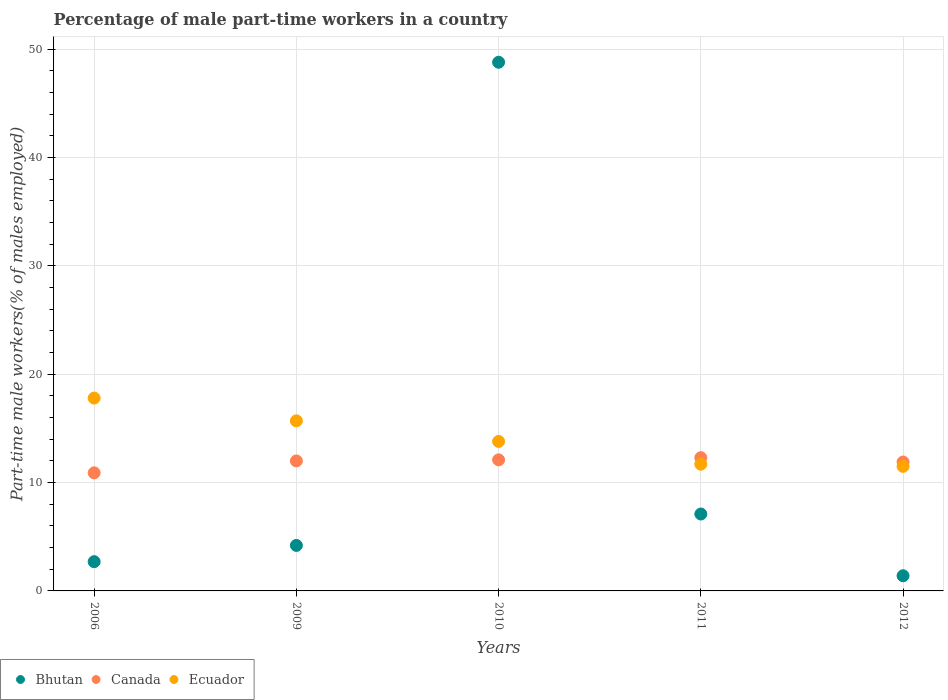How many different coloured dotlines are there?
Keep it short and to the point. 3. Is the number of dotlines equal to the number of legend labels?
Offer a very short reply. Yes. What is the percentage of male part-time workers in Canada in 2011?
Your answer should be compact. 12.3. Across all years, what is the maximum percentage of male part-time workers in Ecuador?
Provide a succinct answer. 17.8. Across all years, what is the minimum percentage of male part-time workers in Bhutan?
Your answer should be compact. 1.4. What is the total percentage of male part-time workers in Canada in the graph?
Keep it short and to the point. 59.2. What is the difference between the percentage of male part-time workers in Canada in 2006 and that in 2009?
Offer a very short reply. -1.1. What is the difference between the percentage of male part-time workers in Canada in 2011 and the percentage of male part-time workers in Bhutan in 2009?
Provide a succinct answer. 8.1. What is the average percentage of male part-time workers in Canada per year?
Your answer should be very brief. 11.84. In the year 2006, what is the difference between the percentage of male part-time workers in Canada and percentage of male part-time workers in Ecuador?
Ensure brevity in your answer.  -6.9. What is the ratio of the percentage of male part-time workers in Ecuador in 2006 to that in 2011?
Provide a succinct answer. 1.52. Is the percentage of male part-time workers in Bhutan in 2009 less than that in 2012?
Your answer should be very brief. No. What is the difference between the highest and the second highest percentage of male part-time workers in Ecuador?
Your answer should be compact. 2.1. What is the difference between the highest and the lowest percentage of male part-time workers in Ecuador?
Provide a succinct answer. 6.3. In how many years, is the percentage of male part-time workers in Ecuador greater than the average percentage of male part-time workers in Ecuador taken over all years?
Provide a succinct answer. 2. Is the sum of the percentage of male part-time workers in Bhutan in 2006 and 2011 greater than the maximum percentage of male part-time workers in Ecuador across all years?
Your answer should be compact. No. How many dotlines are there?
Provide a short and direct response. 3. How many years are there in the graph?
Your response must be concise. 5. Are the values on the major ticks of Y-axis written in scientific E-notation?
Provide a short and direct response. No. How many legend labels are there?
Ensure brevity in your answer.  3. How are the legend labels stacked?
Offer a very short reply. Horizontal. What is the title of the graph?
Your answer should be very brief. Percentage of male part-time workers in a country. Does "France" appear as one of the legend labels in the graph?
Keep it short and to the point. No. What is the label or title of the Y-axis?
Give a very brief answer. Part-time male workers(% of males employed). What is the Part-time male workers(% of males employed) of Bhutan in 2006?
Offer a terse response. 2.7. What is the Part-time male workers(% of males employed) of Canada in 2006?
Provide a succinct answer. 10.9. What is the Part-time male workers(% of males employed) in Ecuador in 2006?
Your answer should be compact. 17.8. What is the Part-time male workers(% of males employed) of Bhutan in 2009?
Keep it short and to the point. 4.2. What is the Part-time male workers(% of males employed) of Ecuador in 2009?
Make the answer very short. 15.7. What is the Part-time male workers(% of males employed) of Bhutan in 2010?
Your response must be concise. 48.8. What is the Part-time male workers(% of males employed) of Canada in 2010?
Your answer should be very brief. 12.1. What is the Part-time male workers(% of males employed) of Ecuador in 2010?
Keep it short and to the point. 13.8. What is the Part-time male workers(% of males employed) of Bhutan in 2011?
Your answer should be very brief. 7.1. What is the Part-time male workers(% of males employed) in Canada in 2011?
Your response must be concise. 12.3. What is the Part-time male workers(% of males employed) in Ecuador in 2011?
Your response must be concise. 11.7. What is the Part-time male workers(% of males employed) in Bhutan in 2012?
Your response must be concise. 1.4. What is the Part-time male workers(% of males employed) in Canada in 2012?
Offer a very short reply. 11.9. Across all years, what is the maximum Part-time male workers(% of males employed) in Bhutan?
Your answer should be very brief. 48.8. Across all years, what is the maximum Part-time male workers(% of males employed) of Canada?
Offer a very short reply. 12.3. Across all years, what is the maximum Part-time male workers(% of males employed) of Ecuador?
Offer a very short reply. 17.8. Across all years, what is the minimum Part-time male workers(% of males employed) in Bhutan?
Make the answer very short. 1.4. Across all years, what is the minimum Part-time male workers(% of males employed) in Canada?
Your answer should be compact. 10.9. Across all years, what is the minimum Part-time male workers(% of males employed) in Ecuador?
Make the answer very short. 11.5. What is the total Part-time male workers(% of males employed) of Bhutan in the graph?
Your answer should be very brief. 64.2. What is the total Part-time male workers(% of males employed) of Canada in the graph?
Make the answer very short. 59.2. What is the total Part-time male workers(% of males employed) of Ecuador in the graph?
Give a very brief answer. 70.5. What is the difference between the Part-time male workers(% of males employed) in Bhutan in 2006 and that in 2009?
Offer a very short reply. -1.5. What is the difference between the Part-time male workers(% of males employed) in Bhutan in 2006 and that in 2010?
Offer a terse response. -46.1. What is the difference between the Part-time male workers(% of males employed) of Canada in 2006 and that in 2010?
Your answer should be compact. -1.2. What is the difference between the Part-time male workers(% of males employed) in Bhutan in 2006 and that in 2011?
Your answer should be very brief. -4.4. What is the difference between the Part-time male workers(% of males employed) of Ecuador in 2006 and that in 2011?
Offer a very short reply. 6.1. What is the difference between the Part-time male workers(% of males employed) of Canada in 2006 and that in 2012?
Keep it short and to the point. -1. What is the difference between the Part-time male workers(% of males employed) of Ecuador in 2006 and that in 2012?
Offer a very short reply. 6.3. What is the difference between the Part-time male workers(% of males employed) of Bhutan in 2009 and that in 2010?
Keep it short and to the point. -44.6. What is the difference between the Part-time male workers(% of males employed) of Ecuador in 2009 and that in 2010?
Your answer should be compact. 1.9. What is the difference between the Part-time male workers(% of males employed) of Canada in 2009 and that in 2011?
Your answer should be compact. -0.3. What is the difference between the Part-time male workers(% of males employed) of Ecuador in 2009 and that in 2011?
Offer a terse response. 4. What is the difference between the Part-time male workers(% of males employed) in Bhutan in 2009 and that in 2012?
Offer a terse response. 2.8. What is the difference between the Part-time male workers(% of males employed) of Canada in 2009 and that in 2012?
Your answer should be compact. 0.1. What is the difference between the Part-time male workers(% of males employed) of Ecuador in 2009 and that in 2012?
Make the answer very short. 4.2. What is the difference between the Part-time male workers(% of males employed) in Bhutan in 2010 and that in 2011?
Keep it short and to the point. 41.7. What is the difference between the Part-time male workers(% of males employed) in Ecuador in 2010 and that in 2011?
Your response must be concise. 2.1. What is the difference between the Part-time male workers(% of males employed) in Bhutan in 2010 and that in 2012?
Offer a terse response. 47.4. What is the difference between the Part-time male workers(% of males employed) in Canada in 2006 and the Part-time male workers(% of males employed) in Ecuador in 2010?
Ensure brevity in your answer.  -2.9. What is the difference between the Part-time male workers(% of males employed) in Bhutan in 2006 and the Part-time male workers(% of males employed) in Canada in 2011?
Offer a very short reply. -9.6. What is the difference between the Part-time male workers(% of males employed) in Bhutan in 2006 and the Part-time male workers(% of males employed) in Ecuador in 2011?
Offer a very short reply. -9. What is the difference between the Part-time male workers(% of males employed) of Bhutan in 2006 and the Part-time male workers(% of males employed) of Canada in 2012?
Give a very brief answer. -9.2. What is the difference between the Part-time male workers(% of males employed) of Bhutan in 2009 and the Part-time male workers(% of males employed) of Canada in 2010?
Your response must be concise. -7.9. What is the difference between the Part-time male workers(% of males employed) in Bhutan in 2009 and the Part-time male workers(% of males employed) in Ecuador in 2010?
Give a very brief answer. -9.6. What is the difference between the Part-time male workers(% of males employed) in Canada in 2009 and the Part-time male workers(% of males employed) in Ecuador in 2010?
Your response must be concise. -1.8. What is the difference between the Part-time male workers(% of males employed) of Bhutan in 2009 and the Part-time male workers(% of males employed) of Canada in 2012?
Give a very brief answer. -7.7. What is the difference between the Part-time male workers(% of males employed) of Bhutan in 2009 and the Part-time male workers(% of males employed) of Ecuador in 2012?
Keep it short and to the point. -7.3. What is the difference between the Part-time male workers(% of males employed) of Bhutan in 2010 and the Part-time male workers(% of males employed) of Canada in 2011?
Make the answer very short. 36.5. What is the difference between the Part-time male workers(% of males employed) of Bhutan in 2010 and the Part-time male workers(% of males employed) of Ecuador in 2011?
Ensure brevity in your answer.  37.1. What is the difference between the Part-time male workers(% of males employed) in Canada in 2010 and the Part-time male workers(% of males employed) in Ecuador in 2011?
Your response must be concise. 0.4. What is the difference between the Part-time male workers(% of males employed) in Bhutan in 2010 and the Part-time male workers(% of males employed) in Canada in 2012?
Give a very brief answer. 36.9. What is the difference between the Part-time male workers(% of males employed) in Bhutan in 2010 and the Part-time male workers(% of males employed) in Ecuador in 2012?
Your response must be concise. 37.3. What is the difference between the Part-time male workers(% of males employed) of Bhutan in 2011 and the Part-time male workers(% of males employed) of Canada in 2012?
Your answer should be compact. -4.8. What is the difference between the Part-time male workers(% of males employed) in Bhutan in 2011 and the Part-time male workers(% of males employed) in Ecuador in 2012?
Your answer should be compact. -4.4. What is the average Part-time male workers(% of males employed) in Bhutan per year?
Make the answer very short. 12.84. What is the average Part-time male workers(% of males employed) in Canada per year?
Your answer should be compact. 11.84. What is the average Part-time male workers(% of males employed) in Ecuador per year?
Provide a short and direct response. 14.1. In the year 2006, what is the difference between the Part-time male workers(% of males employed) of Bhutan and Part-time male workers(% of males employed) of Ecuador?
Make the answer very short. -15.1. In the year 2006, what is the difference between the Part-time male workers(% of males employed) of Canada and Part-time male workers(% of males employed) of Ecuador?
Provide a succinct answer. -6.9. In the year 2010, what is the difference between the Part-time male workers(% of males employed) of Bhutan and Part-time male workers(% of males employed) of Canada?
Give a very brief answer. 36.7. In the year 2010, what is the difference between the Part-time male workers(% of males employed) in Bhutan and Part-time male workers(% of males employed) in Ecuador?
Keep it short and to the point. 35. In the year 2010, what is the difference between the Part-time male workers(% of males employed) in Canada and Part-time male workers(% of males employed) in Ecuador?
Ensure brevity in your answer.  -1.7. In the year 2012, what is the difference between the Part-time male workers(% of males employed) in Bhutan and Part-time male workers(% of males employed) in Canada?
Provide a succinct answer. -10.5. In the year 2012, what is the difference between the Part-time male workers(% of males employed) of Bhutan and Part-time male workers(% of males employed) of Ecuador?
Keep it short and to the point. -10.1. In the year 2012, what is the difference between the Part-time male workers(% of males employed) of Canada and Part-time male workers(% of males employed) of Ecuador?
Give a very brief answer. 0.4. What is the ratio of the Part-time male workers(% of males employed) in Bhutan in 2006 to that in 2009?
Ensure brevity in your answer.  0.64. What is the ratio of the Part-time male workers(% of males employed) of Canada in 2006 to that in 2009?
Your answer should be compact. 0.91. What is the ratio of the Part-time male workers(% of males employed) in Ecuador in 2006 to that in 2009?
Give a very brief answer. 1.13. What is the ratio of the Part-time male workers(% of males employed) in Bhutan in 2006 to that in 2010?
Make the answer very short. 0.06. What is the ratio of the Part-time male workers(% of males employed) of Canada in 2006 to that in 2010?
Provide a short and direct response. 0.9. What is the ratio of the Part-time male workers(% of males employed) in Ecuador in 2006 to that in 2010?
Make the answer very short. 1.29. What is the ratio of the Part-time male workers(% of males employed) in Bhutan in 2006 to that in 2011?
Offer a very short reply. 0.38. What is the ratio of the Part-time male workers(% of males employed) of Canada in 2006 to that in 2011?
Offer a very short reply. 0.89. What is the ratio of the Part-time male workers(% of males employed) of Ecuador in 2006 to that in 2011?
Make the answer very short. 1.52. What is the ratio of the Part-time male workers(% of males employed) in Bhutan in 2006 to that in 2012?
Your answer should be very brief. 1.93. What is the ratio of the Part-time male workers(% of males employed) in Canada in 2006 to that in 2012?
Offer a terse response. 0.92. What is the ratio of the Part-time male workers(% of males employed) in Ecuador in 2006 to that in 2012?
Offer a very short reply. 1.55. What is the ratio of the Part-time male workers(% of males employed) in Bhutan in 2009 to that in 2010?
Provide a short and direct response. 0.09. What is the ratio of the Part-time male workers(% of males employed) in Ecuador in 2009 to that in 2010?
Keep it short and to the point. 1.14. What is the ratio of the Part-time male workers(% of males employed) in Bhutan in 2009 to that in 2011?
Your response must be concise. 0.59. What is the ratio of the Part-time male workers(% of males employed) in Canada in 2009 to that in 2011?
Make the answer very short. 0.98. What is the ratio of the Part-time male workers(% of males employed) in Ecuador in 2009 to that in 2011?
Make the answer very short. 1.34. What is the ratio of the Part-time male workers(% of males employed) of Canada in 2009 to that in 2012?
Offer a very short reply. 1.01. What is the ratio of the Part-time male workers(% of males employed) of Ecuador in 2009 to that in 2012?
Provide a succinct answer. 1.37. What is the ratio of the Part-time male workers(% of males employed) in Bhutan in 2010 to that in 2011?
Your response must be concise. 6.87. What is the ratio of the Part-time male workers(% of males employed) of Canada in 2010 to that in 2011?
Keep it short and to the point. 0.98. What is the ratio of the Part-time male workers(% of males employed) of Ecuador in 2010 to that in 2011?
Your answer should be compact. 1.18. What is the ratio of the Part-time male workers(% of males employed) of Bhutan in 2010 to that in 2012?
Your answer should be compact. 34.86. What is the ratio of the Part-time male workers(% of males employed) of Canada in 2010 to that in 2012?
Make the answer very short. 1.02. What is the ratio of the Part-time male workers(% of males employed) in Ecuador in 2010 to that in 2012?
Keep it short and to the point. 1.2. What is the ratio of the Part-time male workers(% of males employed) of Bhutan in 2011 to that in 2012?
Your answer should be very brief. 5.07. What is the ratio of the Part-time male workers(% of males employed) in Canada in 2011 to that in 2012?
Make the answer very short. 1.03. What is the ratio of the Part-time male workers(% of males employed) of Ecuador in 2011 to that in 2012?
Offer a terse response. 1.02. What is the difference between the highest and the second highest Part-time male workers(% of males employed) in Bhutan?
Give a very brief answer. 41.7. What is the difference between the highest and the second highest Part-time male workers(% of males employed) of Ecuador?
Keep it short and to the point. 2.1. What is the difference between the highest and the lowest Part-time male workers(% of males employed) in Bhutan?
Your answer should be compact. 47.4. What is the difference between the highest and the lowest Part-time male workers(% of males employed) of Canada?
Offer a terse response. 1.4. What is the difference between the highest and the lowest Part-time male workers(% of males employed) of Ecuador?
Your response must be concise. 6.3. 